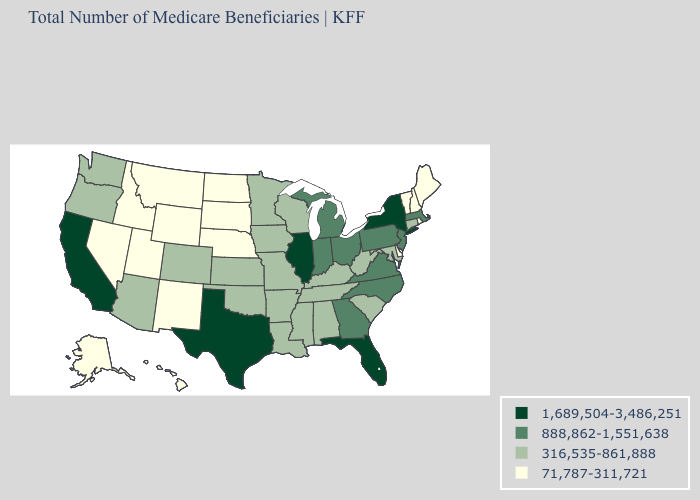Name the states that have a value in the range 1,689,504-3,486,251?
Answer briefly. California, Florida, Illinois, New York, Texas. What is the lowest value in states that border South Carolina?
Write a very short answer. 888,862-1,551,638. What is the value of Idaho?
Concise answer only. 71,787-311,721. What is the highest value in the West ?
Answer briefly. 1,689,504-3,486,251. What is the highest value in the Northeast ?
Give a very brief answer. 1,689,504-3,486,251. Does Oregon have the lowest value in the West?
Be succinct. No. What is the highest value in the USA?
Short answer required. 1,689,504-3,486,251. Name the states that have a value in the range 316,535-861,888?
Short answer required. Alabama, Arizona, Arkansas, Colorado, Connecticut, Iowa, Kansas, Kentucky, Louisiana, Maryland, Minnesota, Mississippi, Missouri, Oklahoma, Oregon, South Carolina, Tennessee, Washington, West Virginia, Wisconsin. Name the states that have a value in the range 1,689,504-3,486,251?
Concise answer only. California, Florida, Illinois, New York, Texas. What is the value of Maine?
Quick response, please. 71,787-311,721. Which states have the lowest value in the West?
Write a very short answer. Alaska, Hawaii, Idaho, Montana, Nevada, New Mexico, Utah, Wyoming. Name the states that have a value in the range 1,689,504-3,486,251?
Write a very short answer. California, Florida, Illinois, New York, Texas. Name the states that have a value in the range 71,787-311,721?
Be succinct. Alaska, Delaware, Hawaii, Idaho, Maine, Montana, Nebraska, Nevada, New Hampshire, New Mexico, North Dakota, Rhode Island, South Dakota, Utah, Vermont, Wyoming. Does the map have missing data?
Write a very short answer. No. Is the legend a continuous bar?
Answer briefly. No. 